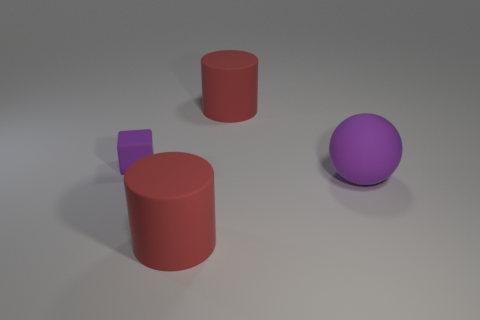Does the large red thing that is in front of the big rubber sphere have the same shape as the thing that is behind the small block?
Offer a terse response. Yes. How many things are big cyan metallic cylinders or big rubber things?
Provide a succinct answer. 3. Are there more matte cylinders to the left of the small purple matte block than small objects?
Offer a very short reply. No. Does the purple ball have the same material as the cube?
Your answer should be compact. Yes. How many objects are objects to the right of the small purple matte cube or large red matte things behind the small purple object?
Keep it short and to the point. 3. What number of other matte blocks are the same color as the block?
Provide a succinct answer. 0. Is the color of the small cube the same as the big ball?
Your response must be concise. Yes. What number of objects are big rubber cylinders that are behind the tiny purple rubber thing or tiny cyan matte blocks?
Keep it short and to the point. 1. There is a cylinder that is behind the red cylinder that is in front of the big matte object behind the cube; what color is it?
Your response must be concise. Red. What is the color of the tiny thing that is made of the same material as the big purple thing?
Provide a short and direct response. Purple. 